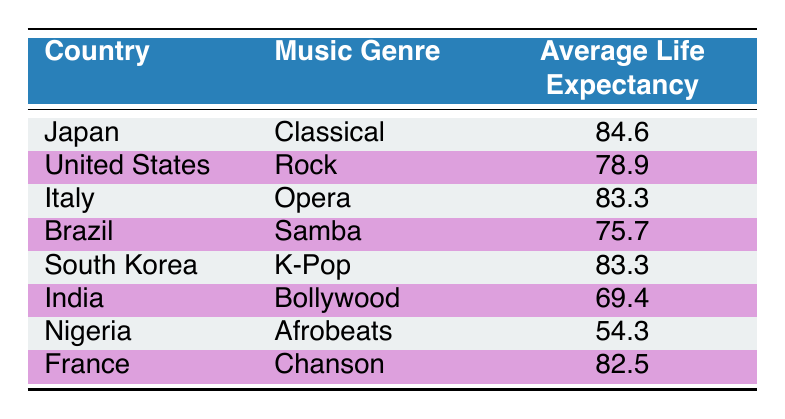What is the average life expectancy in Japan for those who prefer Classical music? The table shows that the average life expectancy in Japan for those who prefer Classical music is listed as 84.6 years.
Answer: 84.6 Which country has the lowest average life expectancy among those listed? By examining the life expectancy values, Nigeria has the lowest average life expectancy at 54.3 years.
Answer: Nigeria What is the average life expectancy of individuals who prefer K-Pop and Bollywood music combined? The life expectancy for K-Pop (South Korea) is 83.3 years, and for Bollywood (India) it is 69.4 years. To find the average, sum them up: (83.3 + 69.4) = 152.7, and then divide by 2: 152.7 / 2 = 76.35.
Answer: 76.35 True or False: The average life expectancy for those who enjoy Rock music in the United States is higher than that of those who prefer Samba in Brazil. The average life expectancy for Rock music in the United States is 78.9 years, while for Samba in Brazil it is 75.7 years. Since 78.9 is greater than 75.7, the statement is true.
Answer: True How does the average life expectancy of individuals who enjoy Opera compare to those who enjoy Chanson? The average life expectancy for Opera (Italy) is 83.3 years, while for Chanson (France) it is 82.5 years. Comparing these values, Opera has a higher life expectancy by 0.8 years (83.3 - 82.5 = 0.8).
Answer: Opera is higher by 0.8 years 